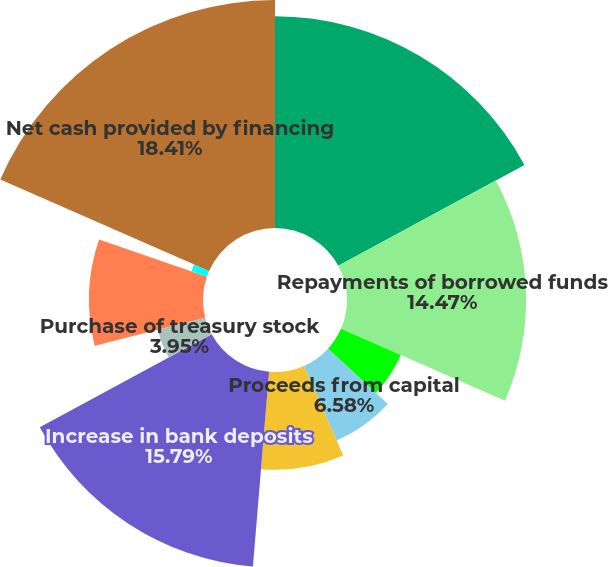<chart> <loc_0><loc_0><loc_500><loc_500><pie_chart><fcel>Proceeds from borrowed funds<fcel>Repayments of borrowed funds<fcel>Repayments of borrowings by<fcel>Proceeds from capital<fcel>Exercise of stock options and<fcel>Increase in bank deposits<fcel>Purchase of treasury stock<fcel>Dividends on common stock<fcel>Excess tax benefits from<fcel>Net cash provided by financing<nl><fcel>17.1%<fcel>14.47%<fcel>5.27%<fcel>6.58%<fcel>7.9%<fcel>15.79%<fcel>3.95%<fcel>9.21%<fcel>1.32%<fcel>18.42%<nl></chart> 